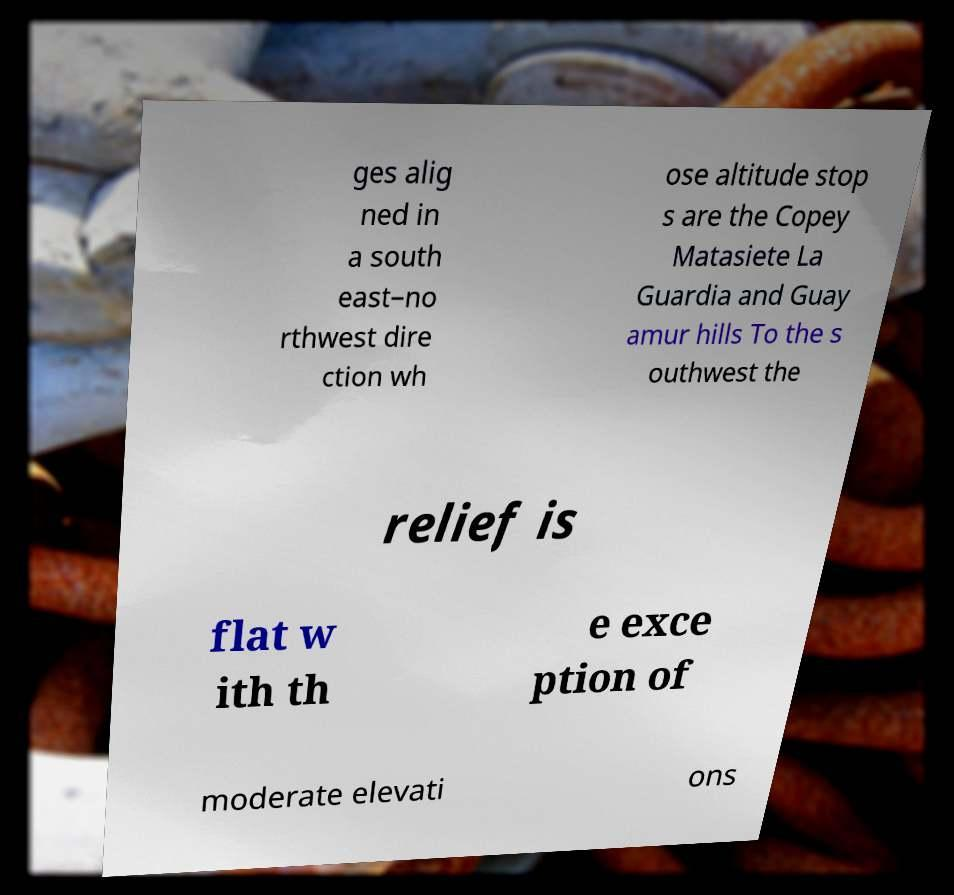Could you assist in decoding the text presented in this image and type it out clearly? ges alig ned in a south east–no rthwest dire ction wh ose altitude stop s are the Copey Matasiete La Guardia and Guay amur hills To the s outhwest the relief is flat w ith th e exce ption of moderate elevati ons 